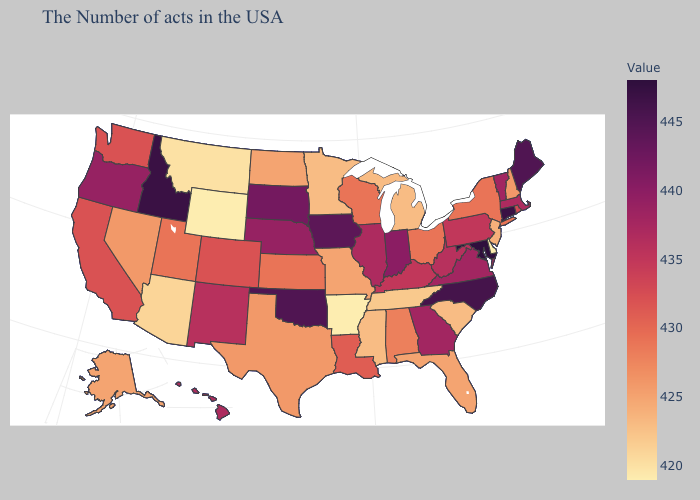Among the states that border Wisconsin , does Minnesota have the highest value?
Concise answer only. No. Does North Carolina have a lower value than Florida?
Quick response, please. No. Does Hawaii have a higher value than Idaho?
Concise answer only. No. Does Maryland have the highest value in the USA?
Concise answer only. Yes. Is the legend a continuous bar?
Keep it brief. Yes. 